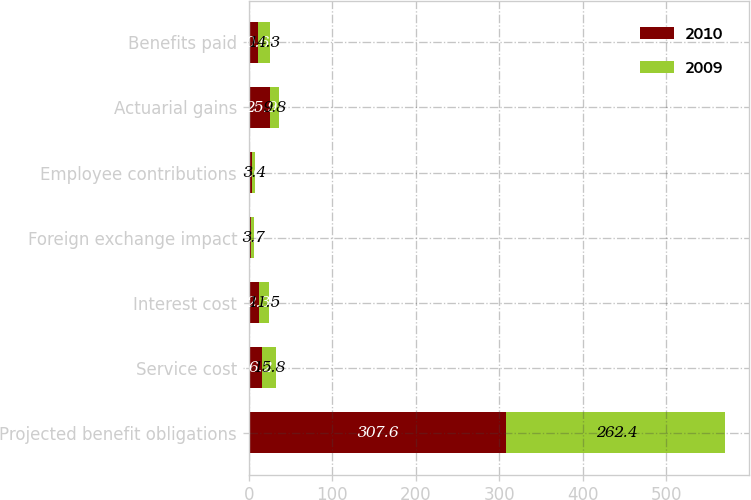Convert chart. <chart><loc_0><loc_0><loc_500><loc_500><stacked_bar_chart><ecel><fcel>Projected benefit obligations<fcel>Service cost<fcel>Interest cost<fcel>Foreign exchange impact<fcel>Employee contributions<fcel>Actuarial gains<fcel>Benefits paid<nl><fcel>2010<fcel>307.6<fcel>16.2<fcel>12.3<fcel>2.2<fcel>3.6<fcel>25.9<fcel>10.6<nl><fcel>2009<fcel>262.4<fcel>15.8<fcel>11.5<fcel>3.7<fcel>3.4<fcel>9.8<fcel>14.3<nl></chart> 